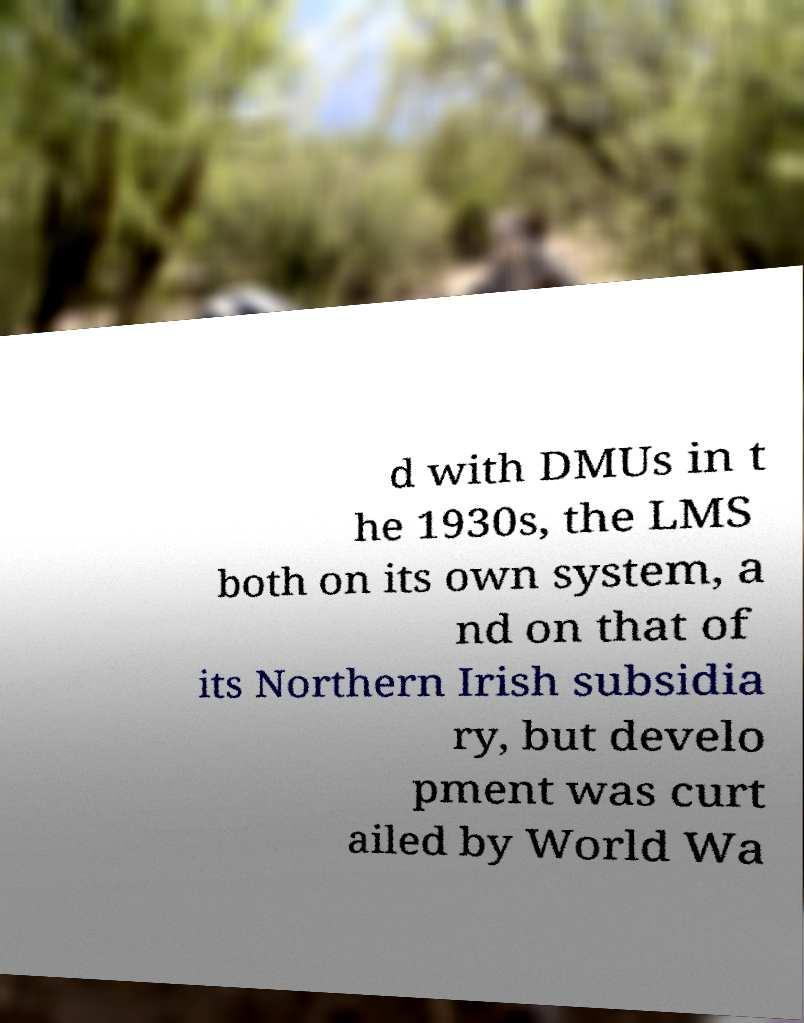Could you extract and type out the text from this image? d with DMUs in t he 1930s, the LMS both on its own system, a nd on that of its Northern Irish subsidia ry, but develo pment was curt ailed by World Wa 